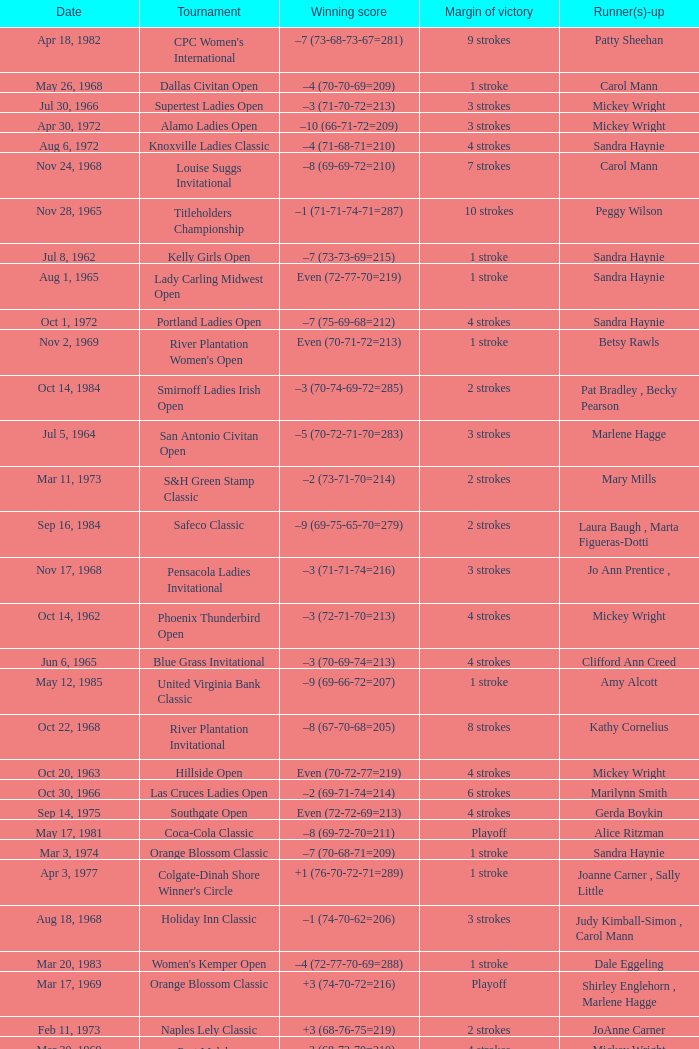What was the margin of victory on Apr 23, 1967? 5 strokes. 